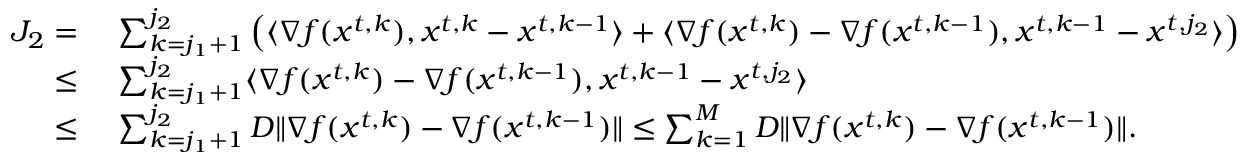Convert formula to latex. <formula><loc_0><loc_0><loc_500><loc_500>\begin{array} { r l } { J _ { 2 } = \ } & { \sum _ { k = j _ { 1 } + 1 } ^ { j _ { 2 } } \left ( \langle \nabla f ( { x } ^ { t , k } ) , { x } ^ { t , k } - { x } ^ { t , k - 1 } \rangle + \langle \nabla f ( { x } ^ { t , k } ) - \nabla f ( { x } ^ { t , k - 1 } ) , { x } ^ { t , k - 1 } - { x } ^ { t , j _ { 2 } } \rangle \right ) } \\ { \leq \ } & { \sum _ { k = j _ { 1 } + 1 } ^ { j _ { 2 } } \langle \nabla f ( { x } ^ { t , k } ) - \nabla f ( { x } ^ { t , k - 1 } ) , { x } ^ { t , k - 1 } - { x } ^ { t , j _ { 2 } } \rangle } \\ { \leq \ } & { \sum _ { k = j _ { 1 } + 1 } ^ { j _ { 2 } } D \| \nabla f ( { x } ^ { t , k } ) - \nabla f ( { x } ^ { t , k - 1 } ) \| \leq \sum _ { k = 1 } ^ { M } D \| \nabla f ( { x } ^ { t , k } ) - \nabla f ( { x } ^ { t , k - 1 } ) \| . } \end{array}</formula> 